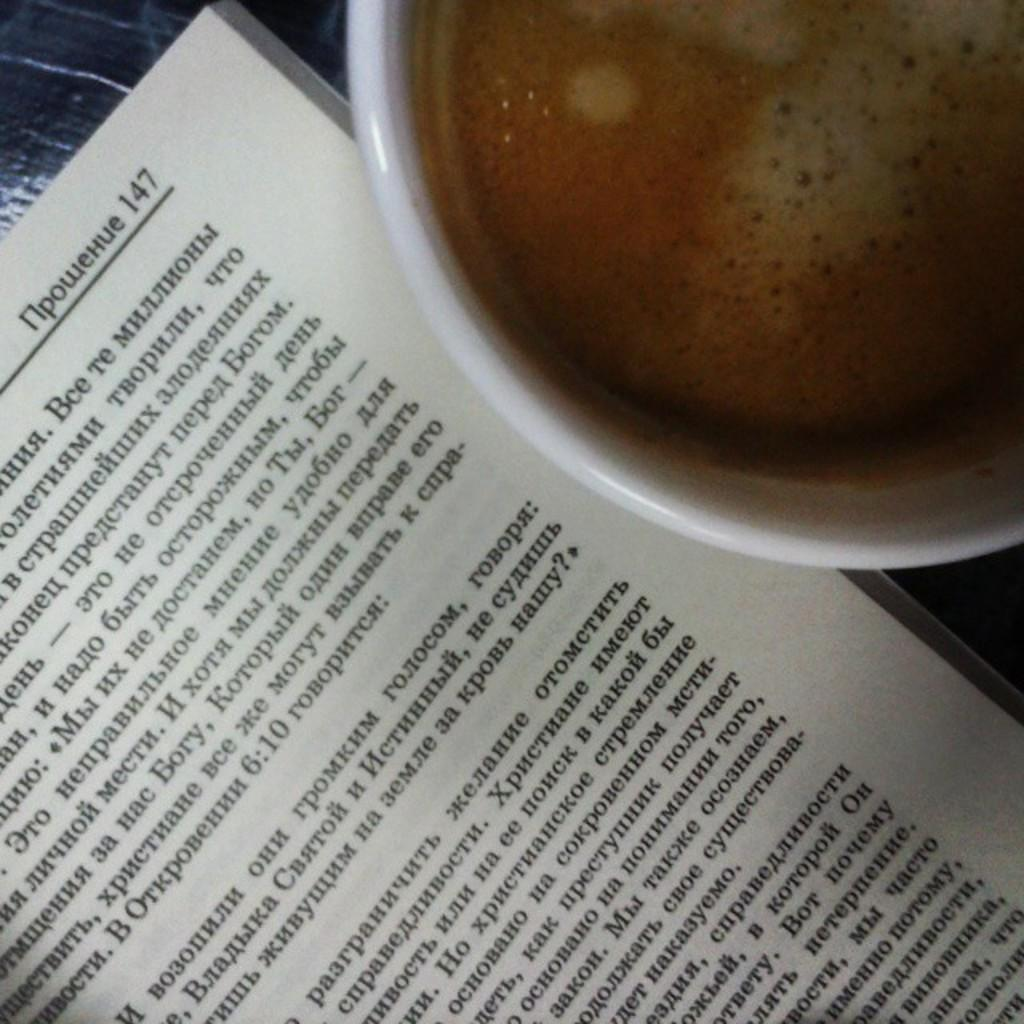Provide a one-sentence caption for the provided image. A book opened to page 147 next to a cup of coffee. 